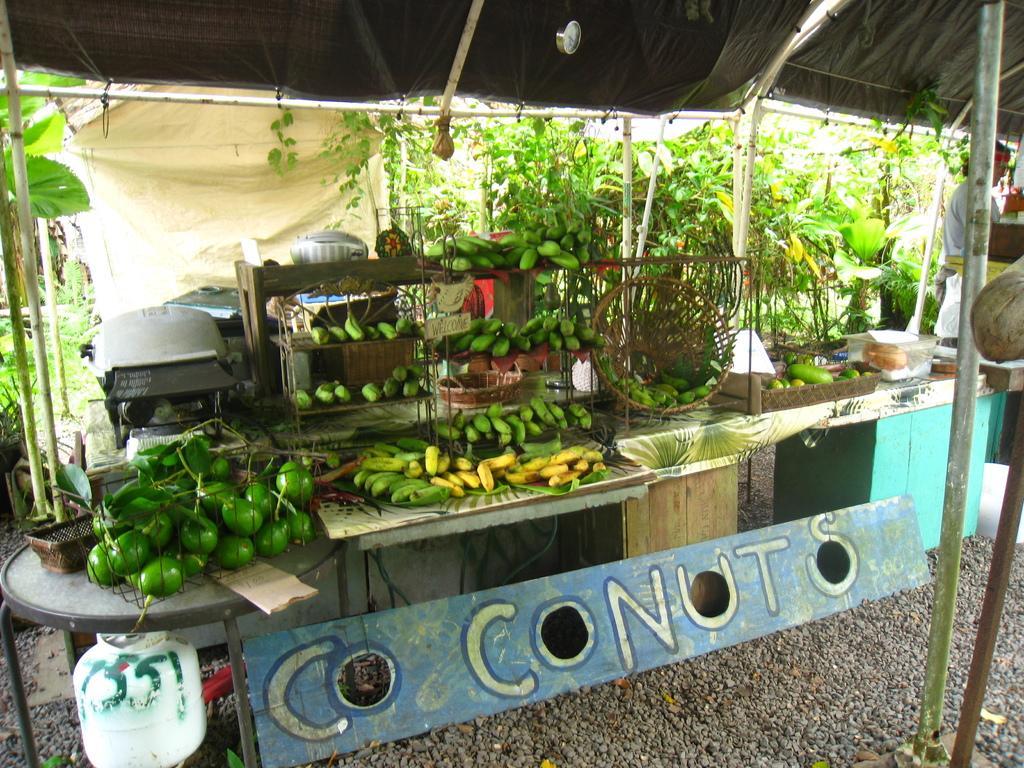Could you give a brief overview of what you see in this image? In this image I can see a tent , under the tent I can see a bench , on bench I can see baskets and fruits, bowls, in front of the bench there is a board, on the board there is a text and under the bench I can see white color cans on the floor on the left side , there are some trees visible back side of tent and there is a person visible on the right side. 